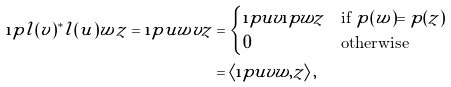Convert formula to latex. <formula><loc_0><loc_0><loc_500><loc_500>\i p { l ( v ) ^ { * } l ( u ) w } { z } = \i p { u w } { v z } & = \begin{cases} \i p u v \i p w z & \text {if $p(w) = p(z)$} \\ 0 & \text {otherwise} \end{cases} \\ & = \left \langle \i p u v w , z \right \rangle ,</formula> 